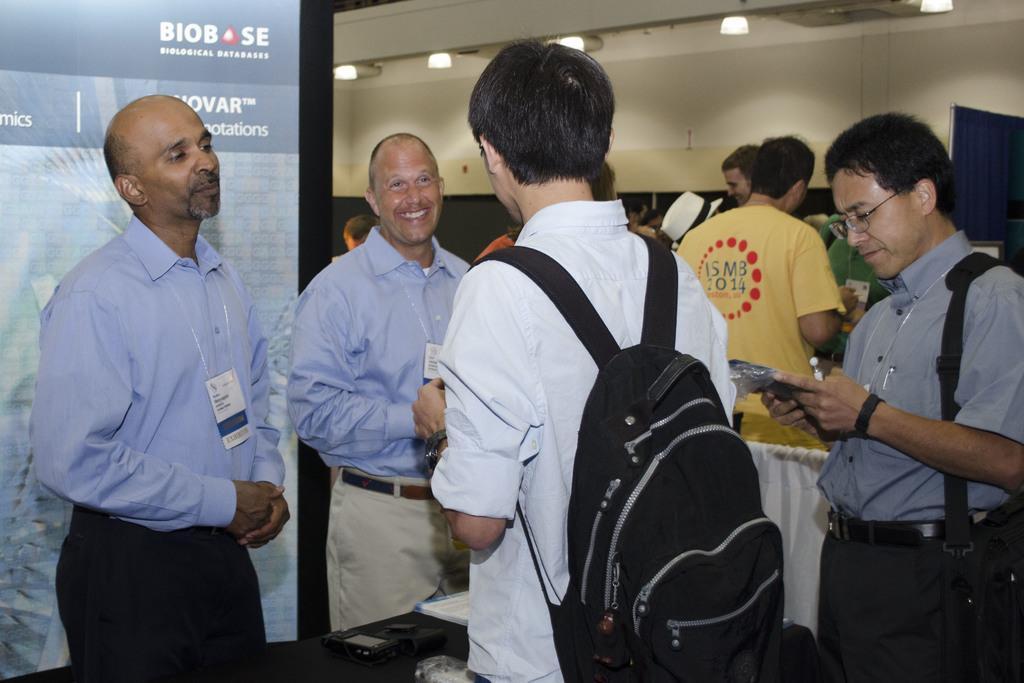Describe this image in one or two sentences. In this image I can see the group of people standing and these people are wearing the different color dresses. I can see two people are wearing the bags. To the left I can see the banner and there are some objects on the black color table. In the back I can see the wall and lights. 